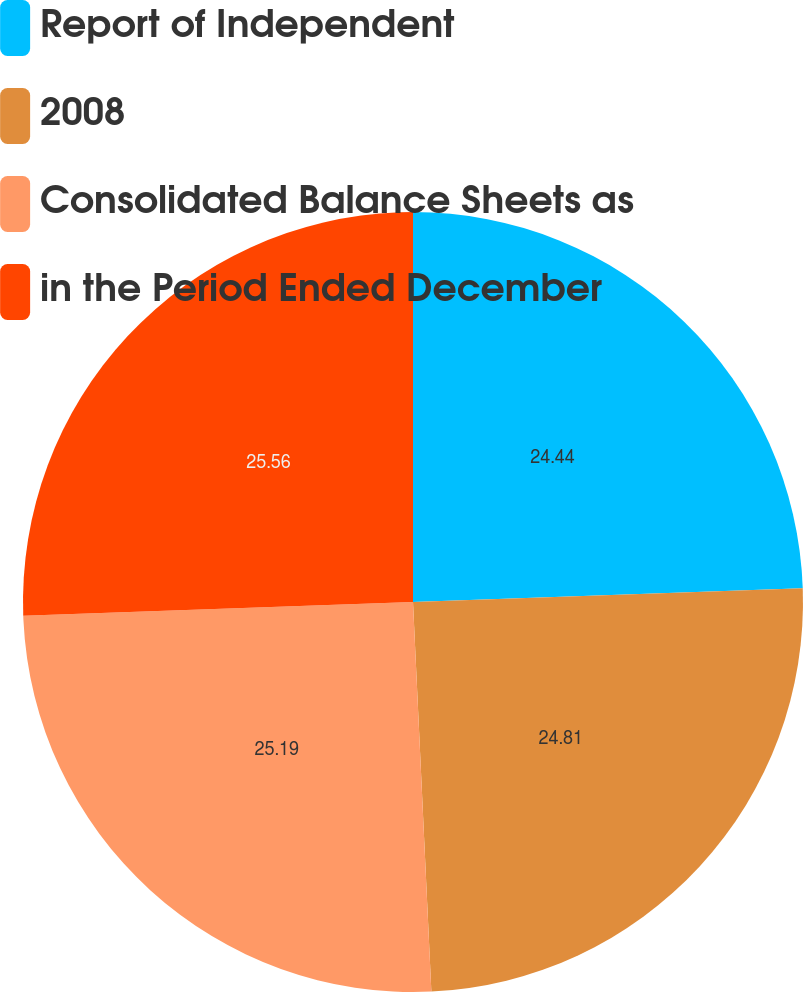Convert chart to OTSL. <chart><loc_0><loc_0><loc_500><loc_500><pie_chart><fcel>Report of Independent<fcel>2008<fcel>Consolidated Balance Sheets as<fcel>in the Period Ended December<nl><fcel>24.44%<fcel>24.81%<fcel>25.19%<fcel>25.56%<nl></chart> 